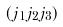<formula> <loc_0><loc_0><loc_500><loc_500>( j _ { 1 } j _ { 2 } j _ { 3 } )</formula> 